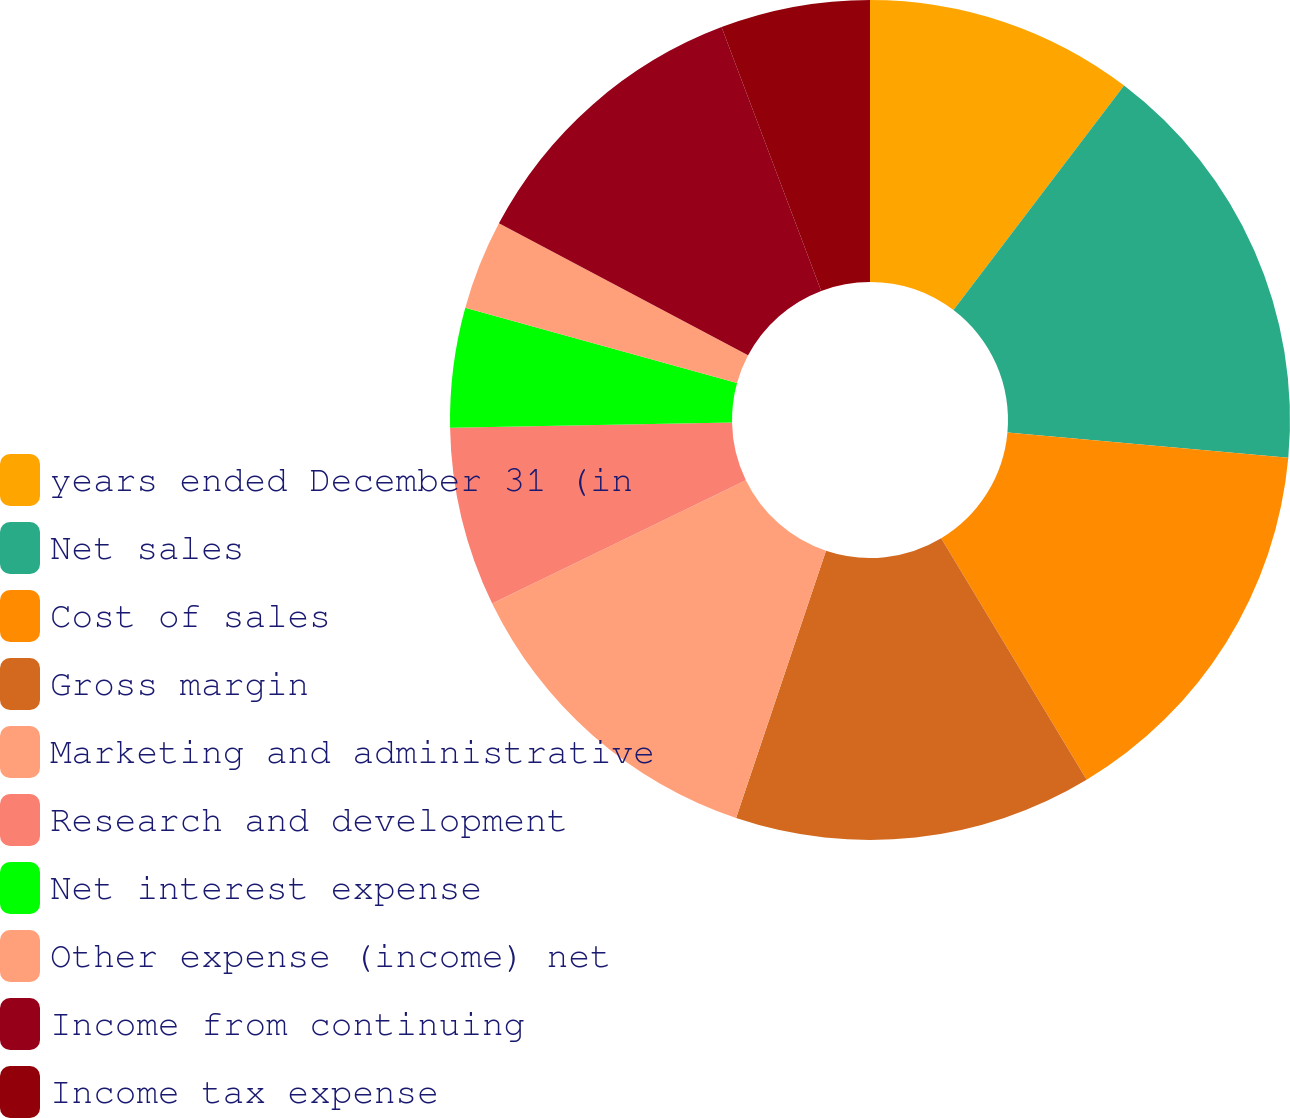Convert chart. <chart><loc_0><loc_0><loc_500><loc_500><pie_chart><fcel>years ended December 31 (in<fcel>Net sales<fcel>Cost of sales<fcel>Gross margin<fcel>Marketing and administrative<fcel>Research and development<fcel>Net interest expense<fcel>Other expense (income) net<fcel>Income from continuing<fcel>Income tax expense<nl><fcel>10.34%<fcel>16.09%<fcel>14.94%<fcel>13.79%<fcel>12.64%<fcel>6.9%<fcel>4.6%<fcel>3.45%<fcel>11.49%<fcel>5.75%<nl></chart> 